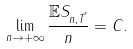<formula> <loc_0><loc_0><loc_500><loc_500>\lim _ { n \to + \infty } \frac { \mathbb { E } S _ { n , \vec { T } } } { n } = C .</formula> 